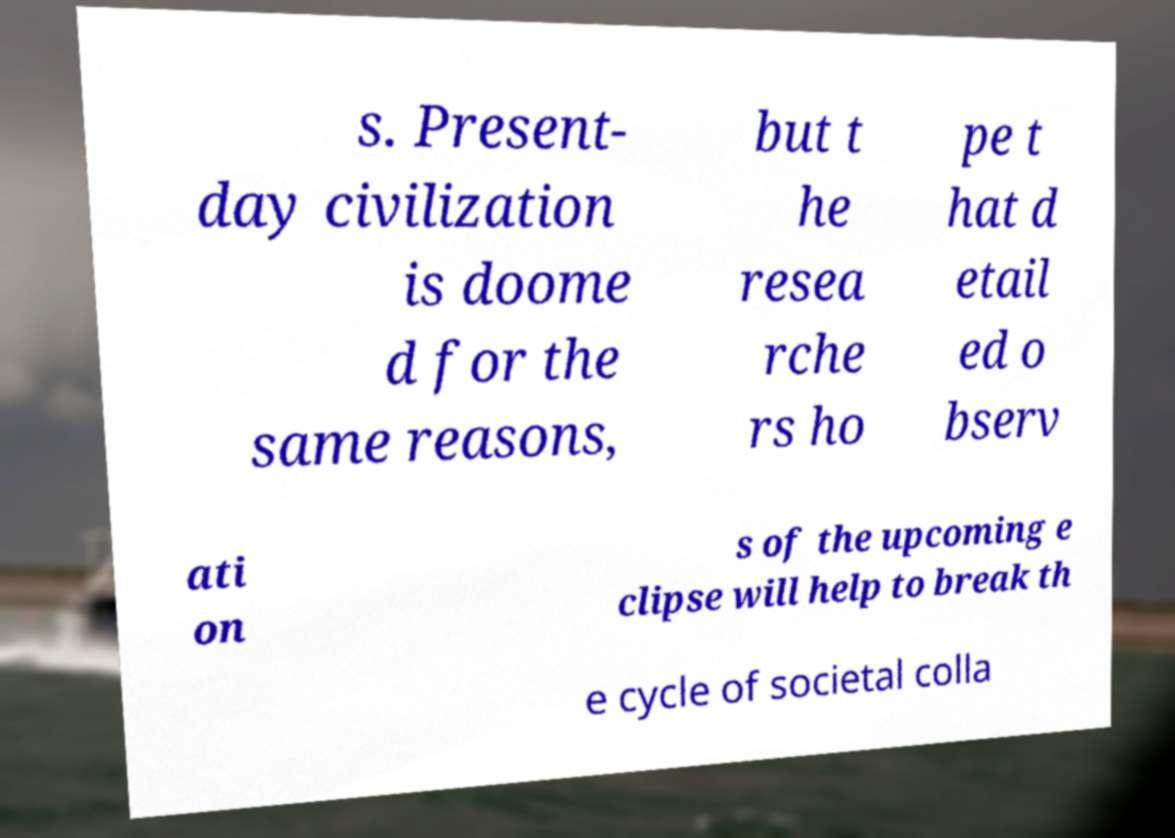There's text embedded in this image that I need extracted. Can you transcribe it verbatim? s. Present- day civilization is doome d for the same reasons, but t he resea rche rs ho pe t hat d etail ed o bserv ati on s of the upcoming e clipse will help to break th e cycle of societal colla 